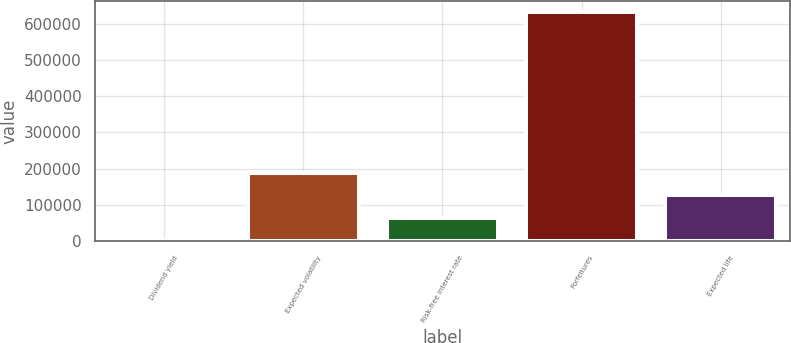<chart> <loc_0><loc_0><loc_500><loc_500><bar_chart><fcel>Dividend yield<fcel>Expected volatility<fcel>Risk-free interest rate<fcel>Forfeitures<fcel>Expected life<nl><fcel>1.29<fcel>189469<fcel>63157.3<fcel>631561<fcel>126313<nl></chart> 